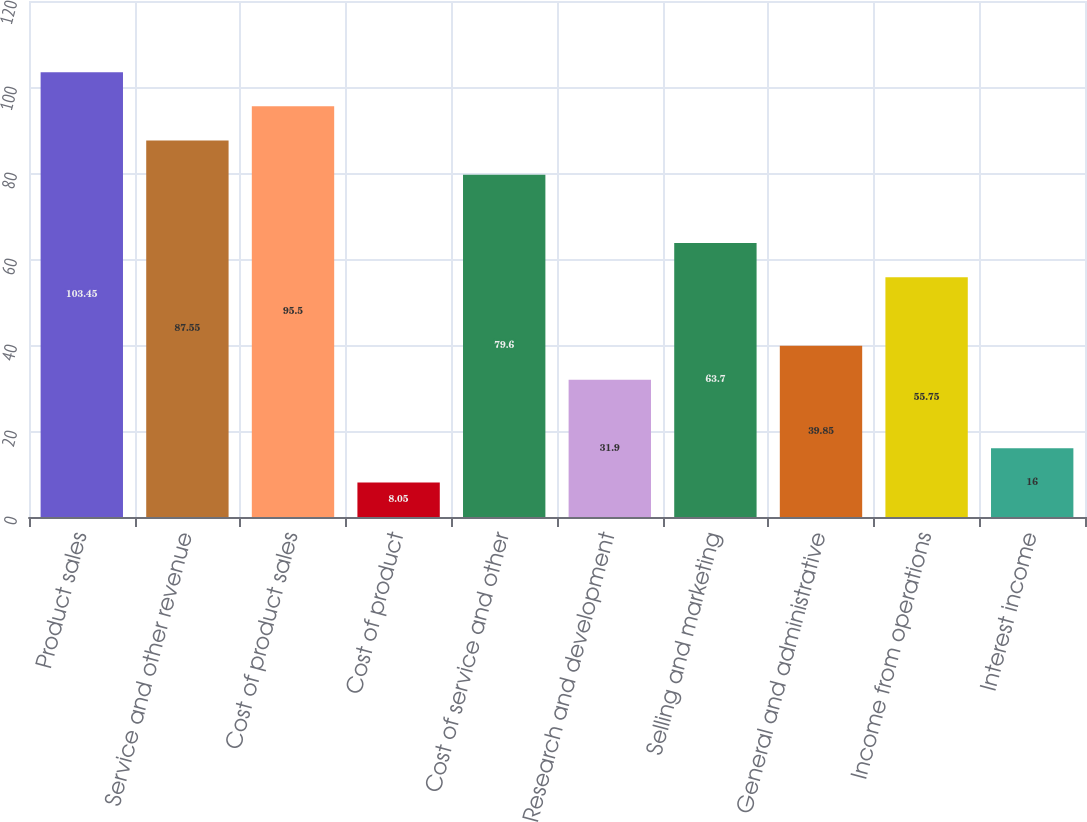<chart> <loc_0><loc_0><loc_500><loc_500><bar_chart><fcel>Product sales<fcel>Service and other revenue<fcel>Cost of product sales<fcel>Cost of product<fcel>Cost of service and other<fcel>Research and development<fcel>Selling and marketing<fcel>General and administrative<fcel>Income from operations<fcel>Interest income<nl><fcel>103.45<fcel>87.55<fcel>95.5<fcel>8.05<fcel>79.6<fcel>31.9<fcel>63.7<fcel>39.85<fcel>55.75<fcel>16<nl></chart> 